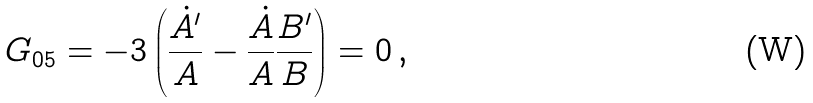Convert formula to latex. <formula><loc_0><loc_0><loc_500><loc_500>G _ { 0 5 } = - 3 \left ( \frac { \dot { A } ^ { \prime } } { A } - \frac { \dot { A } } { A } \frac { B ^ { \prime } } { B } \right ) = 0 \, ,</formula> 